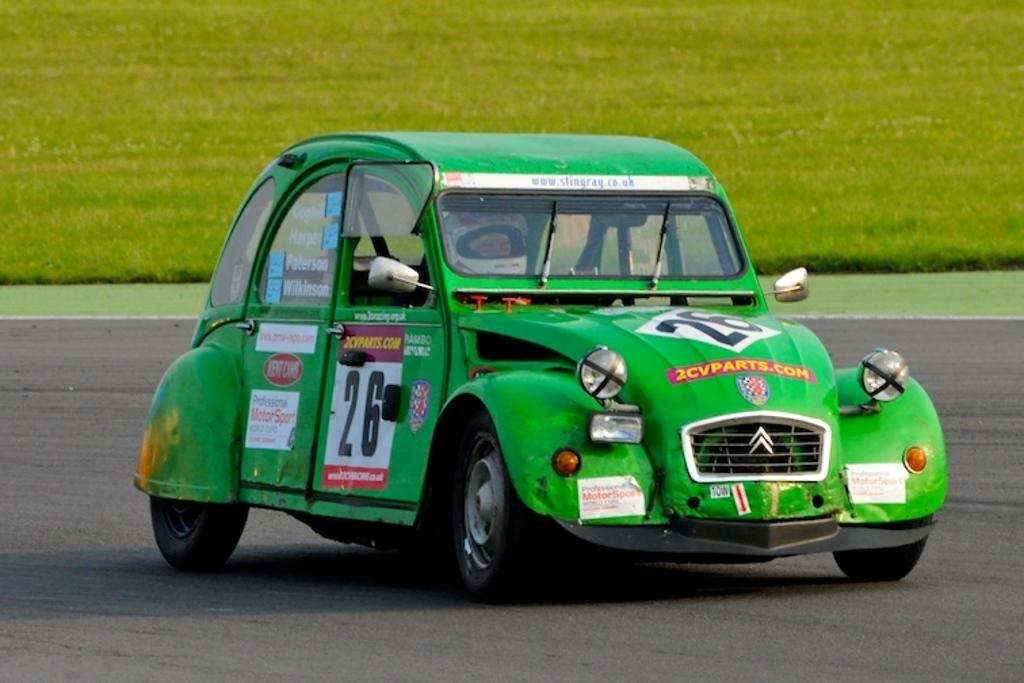Who is present in the image? There is a person in the image. What is the person wearing? The person is wearing a helmet. What is the person doing in the image? The person is riding a car. Where is the car located? The car is on the road. What can be seen in the background of the image? There is grass visible in the background of the image. What type of society is depicted in the image? The image does not depict a society; it shows a person riding a car on the road. 